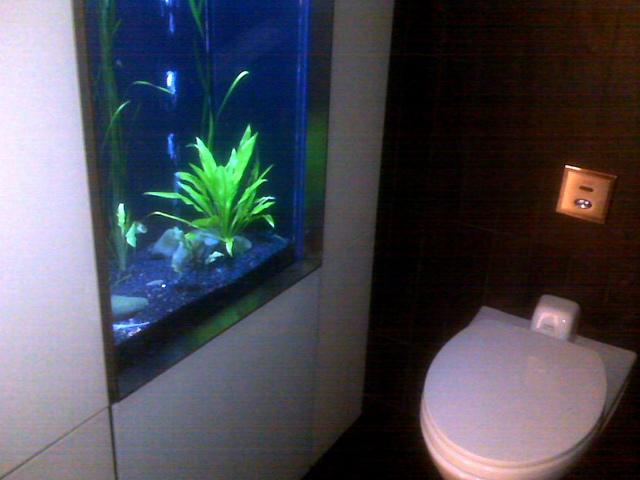Can the fish watch humans eliminate waste?
Quick response, please. Yes. What is on the wall behind the toilet?
Short answer required. Sensor. Where is the aquarium?
Keep it brief. Bathroom. 